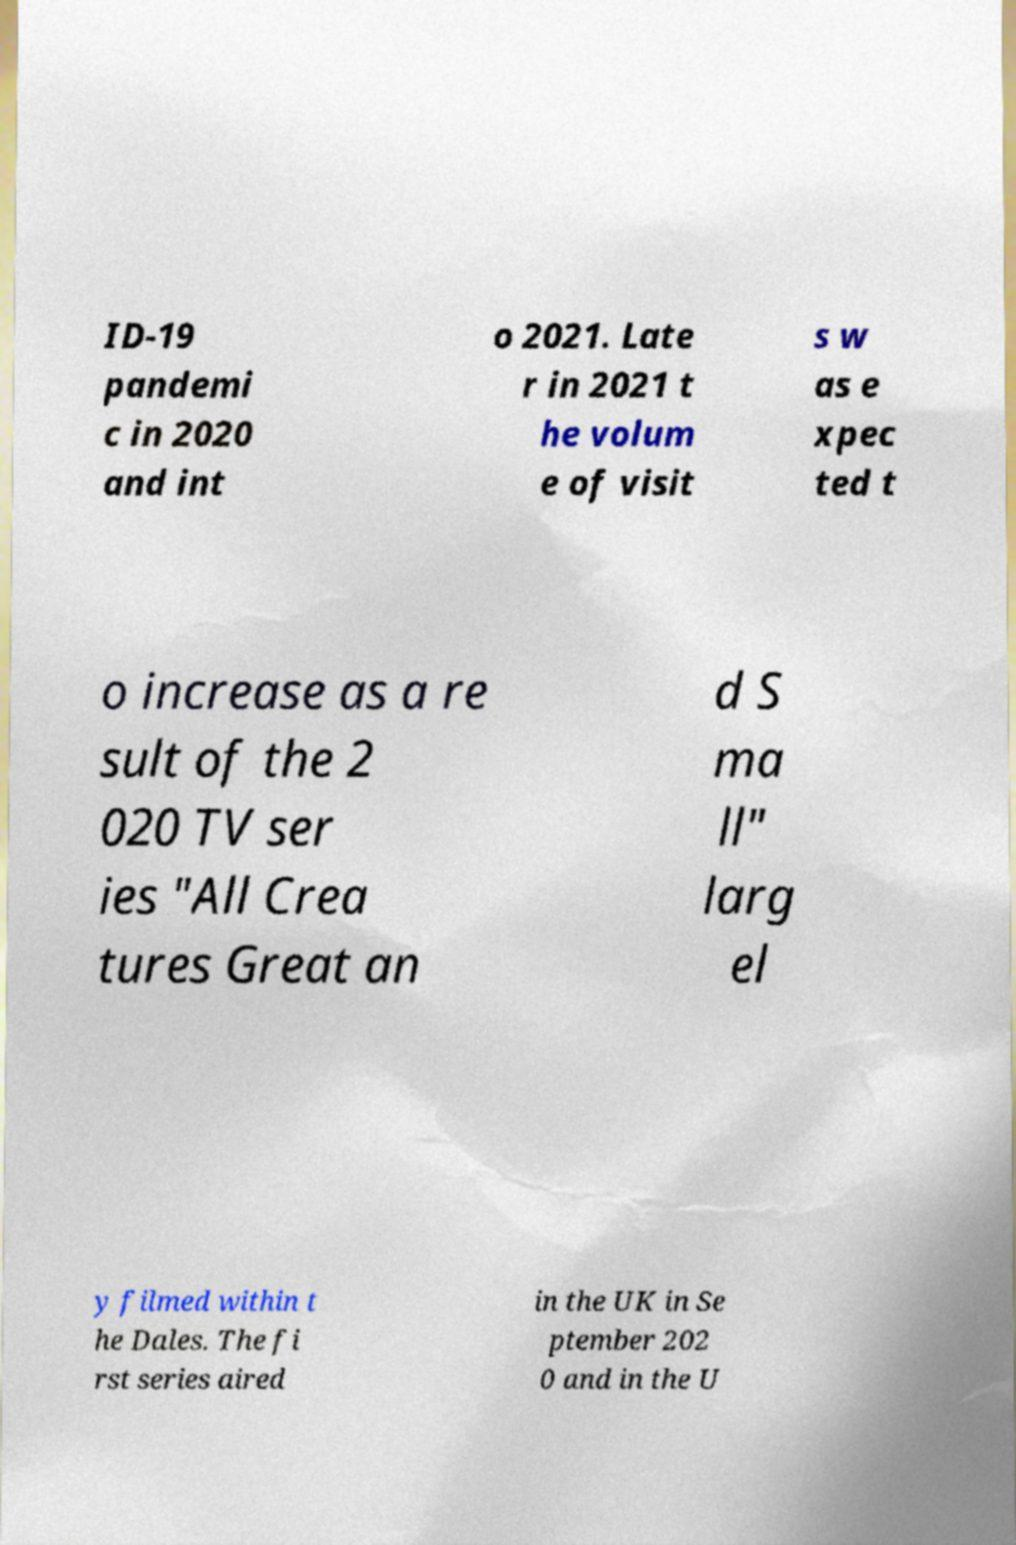Please identify and transcribe the text found in this image. ID-19 pandemi c in 2020 and int o 2021. Late r in 2021 t he volum e of visit s w as e xpec ted t o increase as a re sult of the 2 020 TV ser ies "All Crea tures Great an d S ma ll" larg el y filmed within t he Dales. The fi rst series aired in the UK in Se ptember 202 0 and in the U 